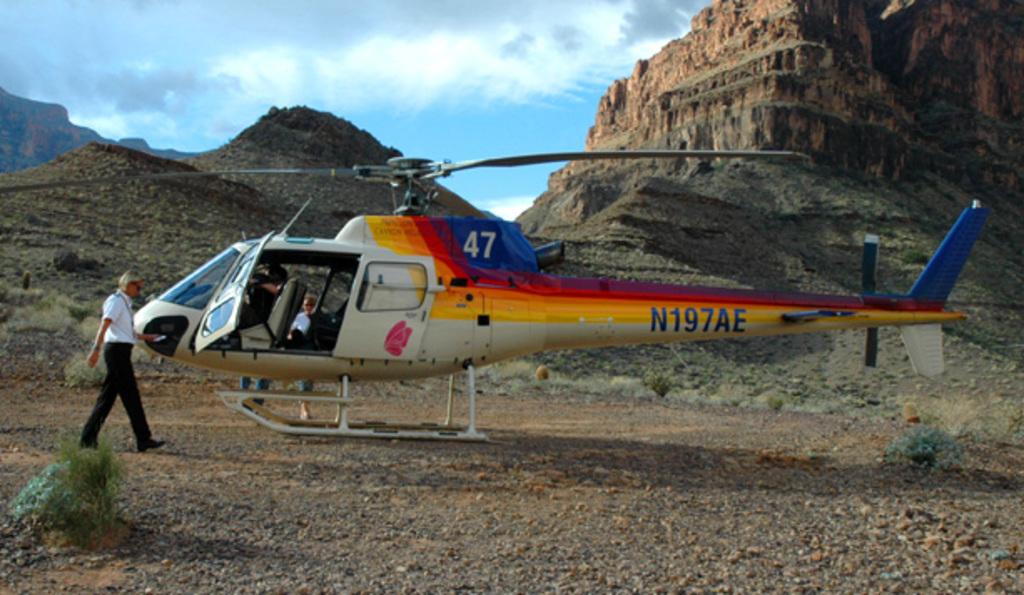Is this helicopter 47?
Keep it short and to the point. Yes. What is the number on the tail?
Offer a very short reply. N197ae. 